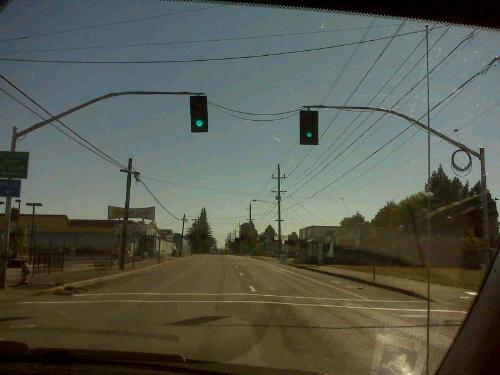Does this road have a crosswalk?
Quick response, please. Yes. Should the driver of the car keep it moving?
Give a very brief answer. Yes. Is there a glare?
Short answer required. Yes. What is the setting?
Give a very brief answer. Street. Is there Zombies in the streets?
Give a very brief answer. No. 